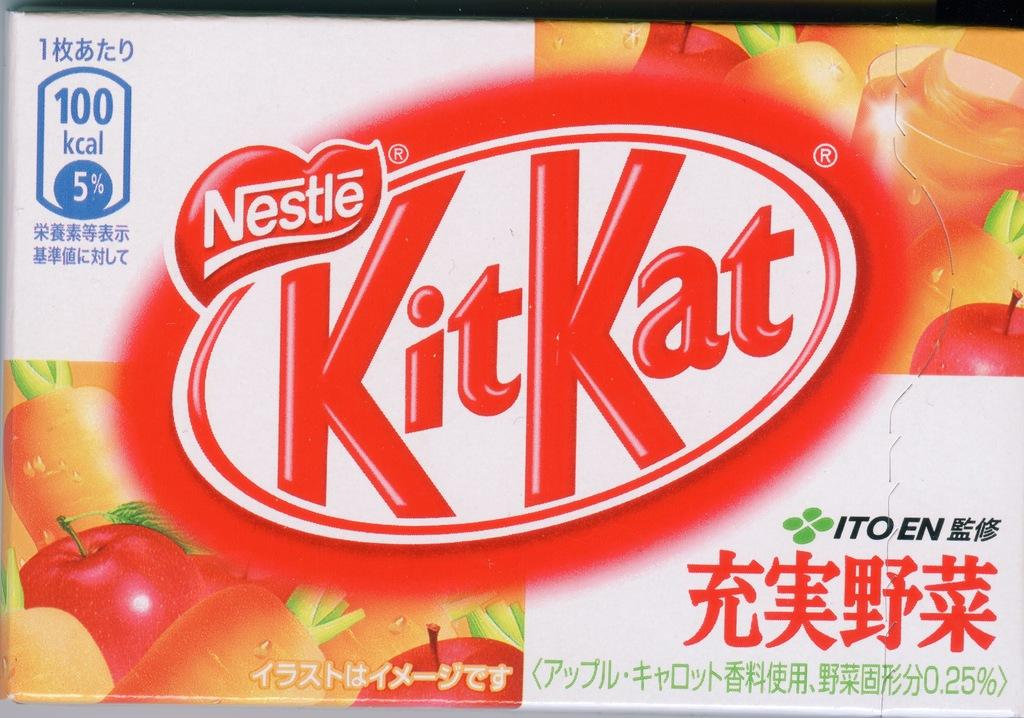What is the main subject of the image? The main subject of the image is a KitKat pack. What can be seen on the KitKat pack? There are images of fruits on the pack and text with calorie information. How much profit does the prison make from selling KitKat packs in the image? There is no prison or profit information present in the image; it is a zoomed-in picture of a KitKat pack with fruit images and calorie information. 